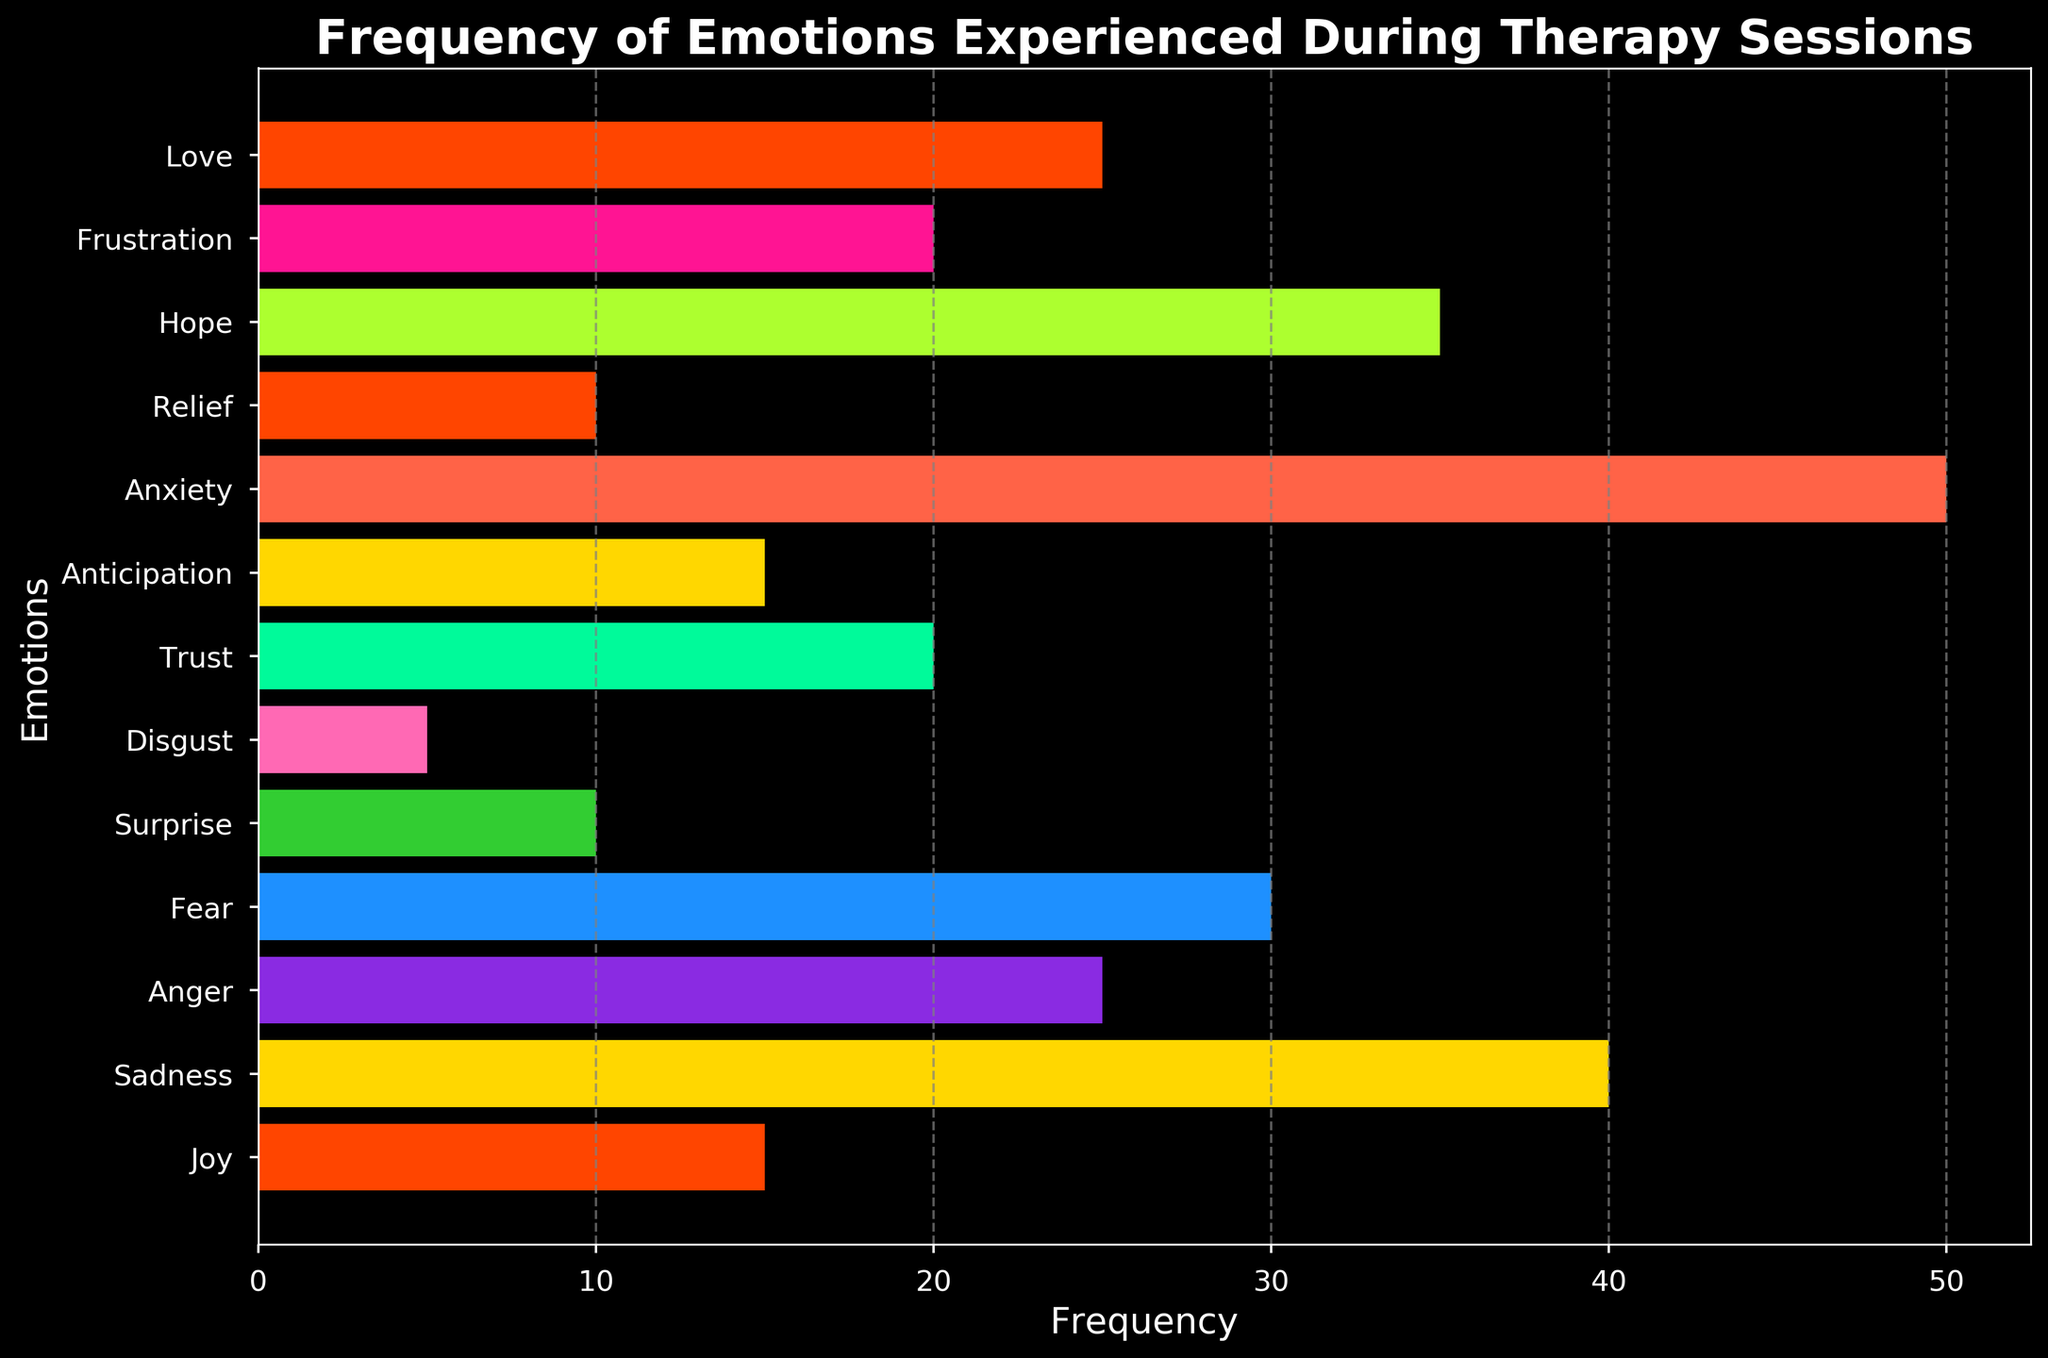What is the most frequently experienced emotion during therapy sessions? To find the most frequently experienced emotion, look for the bar with the greatest length on the horizontal axis. The longest bar corresponds to "Anxiety" with a frequency of 50.
Answer: Anxiety Which emotion is experienced more frequently: Anger or Love? Compare the lengths of the bars for Anger and Love. Anger and Love both have a frequency of 25, so they are experienced equally.
Answer: They are experienced equally Which emotions have a frequency less than 10? Identify the bars shorter than the tick mark representing 10 on the horizontal axis. The emotions with frequencies less than 10 are Disgust with a frequency of 5.
Answer: Disgust What is the combined frequency of Joy and Relief? To find the combined frequency, add the frequencies of Joy and Relief. Joy has a frequency of 15, and Relief has a frequency of 10. Their combined frequency is 15 + 10 = 25.
Answer: 25 Which emotion has the second-highest frequency? To find the second-highest frequency, first identify the highest frequency (Anxiety at 50). The second-highest frequency would be the next longest bar, which is Sadness with a frequency of 40.
Answer: Sadness Is the frequency of Anticipation greater than or equal to the frequency of Joy? Compare the lengths of the bars for Anticipation and Joy. Both Anticipation and Joy have a frequency of 15, so they are equal.
Answer: They are equal What is the total frequency of emotions with frequencies above 30? Identify emotions with frequencies above 30: Anxiety (50), Sadness (40), and Hope (35). Sum these frequencies: 50 + 40 + 35 = 125.
Answer: 125 How does the frequency of Trust compare with Frustration? Compare the lengths of the bars for Trust and Frustration. Both Trust and Frustration have a frequency of 20, so they are equal.
Answer: They are equal Which colors correspond to the emotions with the three lowest frequencies? Find the three shortest bars and note their colors: Disgust (5) in green, Surprise (10) in green, and Relief (10) in brown.
Answer: green, green, brown 